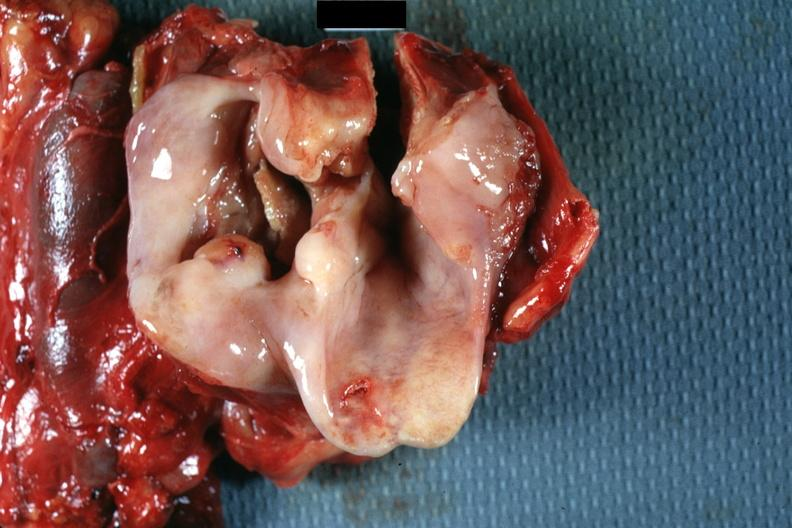where is this?
Answer the question using a single word or phrase. Oral 